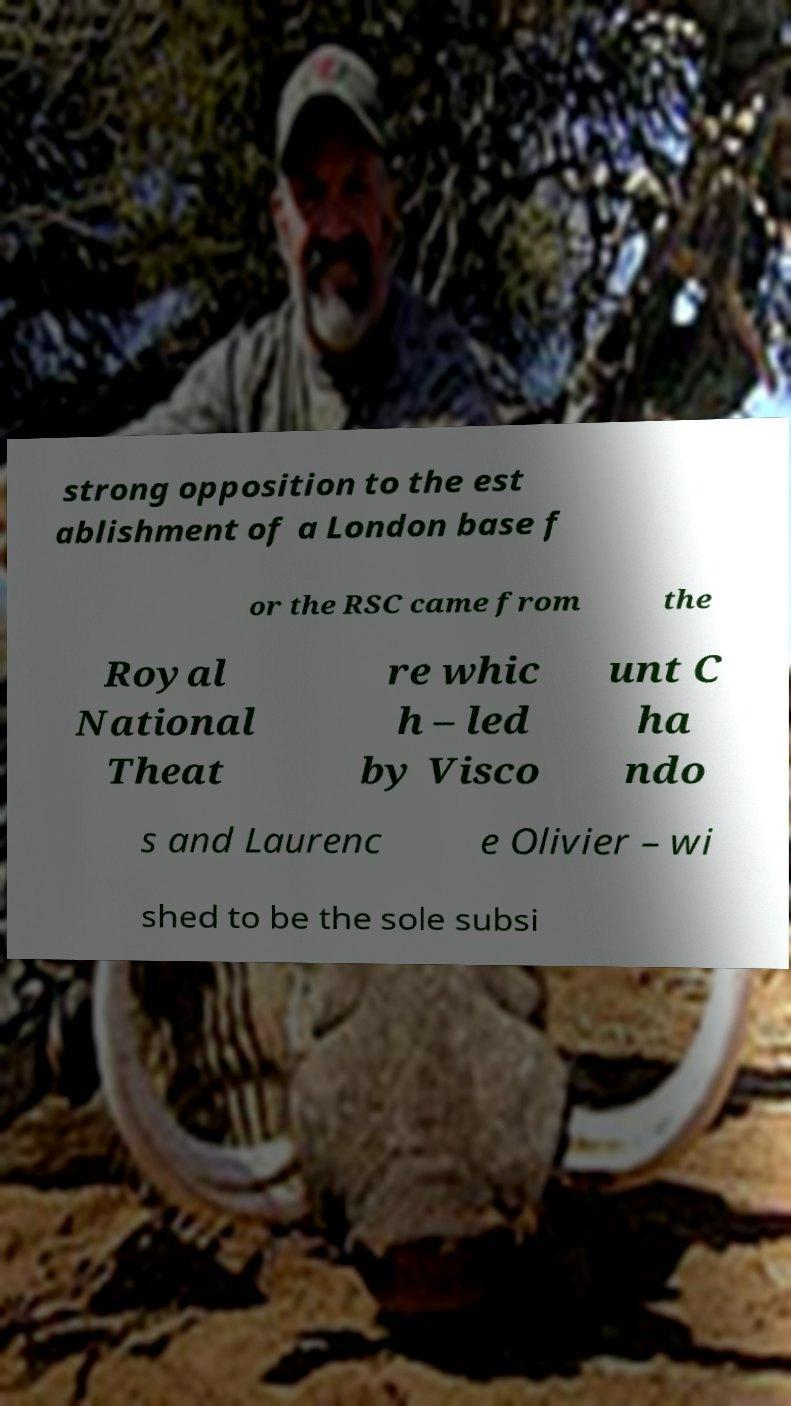What messages or text are displayed in this image? I need them in a readable, typed format. strong opposition to the est ablishment of a London base f or the RSC came from the Royal National Theat re whic h – led by Visco unt C ha ndo s and Laurenc e Olivier – wi shed to be the sole subsi 